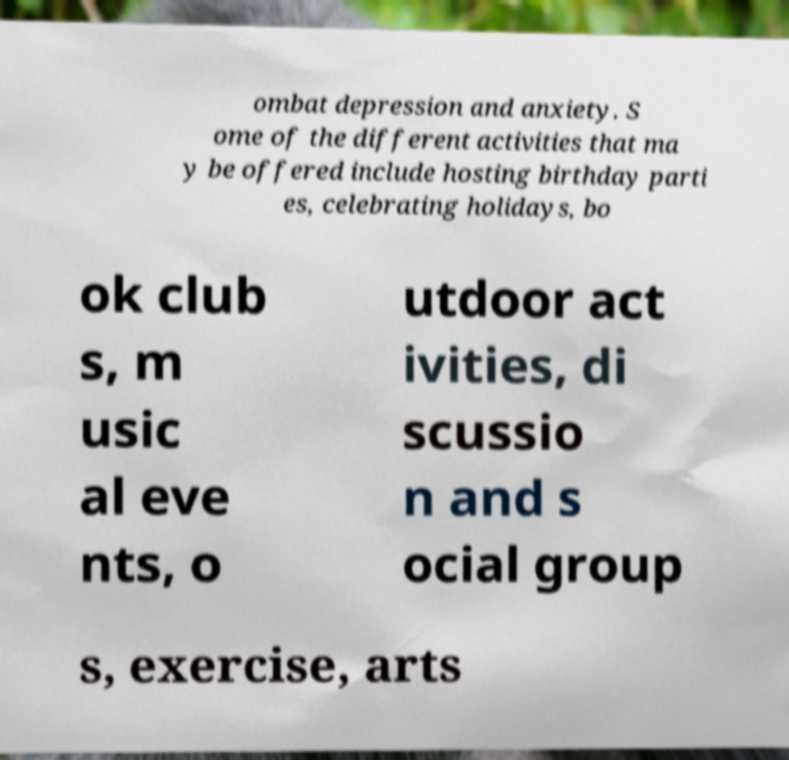Please read and relay the text visible in this image. What does it say? ombat depression and anxiety. S ome of the different activities that ma y be offered include hosting birthday parti es, celebrating holidays, bo ok club s, m usic al eve nts, o utdoor act ivities, di scussio n and s ocial group s, exercise, arts 